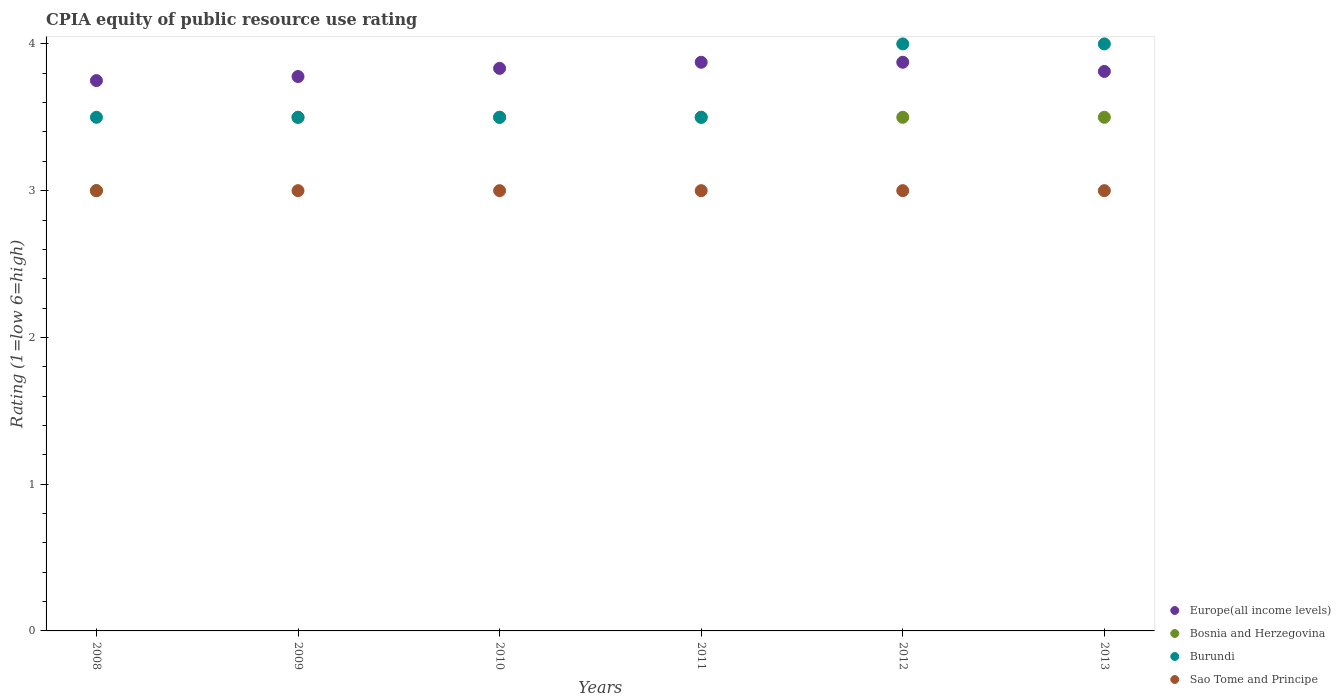Across all years, what is the minimum CPIA rating in Sao Tome and Principe?
Offer a very short reply. 3. In which year was the CPIA rating in Burundi minimum?
Provide a succinct answer. 2008. What is the total CPIA rating in Sao Tome and Principe in the graph?
Provide a succinct answer. 18. What is the difference between the CPIA rating in Bosnia and Herzegovina in 2011 and that in 2012?
Keep it short and to the point. 0. What is the difference between the CPIA rating in Sao Tome and Principe in 2013 and the CPIA rating in Burundi in 2012?
Offer a terse response. -1. What is the average CPIA rating in Sao Tome and Principe per year?
Make the answer very short. 3. In the year 2013, what is the difference between the CPIA rating in Sao Tome and Principe and CPIA rating in Burundi?
Provide a short and direct response. -1. What is the ratio of the CPIA rating in Burundi in 2012 to that in 2013?
Your response must be concise. 1. Is the difference between the CPIA rating in Sao Tome and Principe in 2011 and 2012 greater than the difference between the CPIA rating in Burundi in 2011 and 2012?
Offer a terse response. Yes. What is the difference between the highest and the lowest CPIA rating in Sao Tome and Principe?
Provide a short and direct response. 0. In how many years, is the CPIA rating in Burundi greater than the average CPIA rating in Burundi taken over all years?
Your answer should be compact. 2. Is the CPIA rating in Europe(all income levels) strictly greater than the CPIA rating in Bosnia and Herzegovina over the years?
Make the answer very short. Yes. Is the CPIA rating in Sao Tome and Principe strictly less than the CPIA rating in Bosnia and Herzegovina over the years?
Provide a short and direct response. No. How many years are there in the graph?
Provide a short and direct response. 6. What is the difference between two consecutive major ticks on the Y-axis?
Provide a succinct answer. 1. Does the graph contain any zero values?
Offer a very short reply. No. Does the graph contain grids?
Ensure brevity in your answer.  No. How are the legend labels stacked?
Your answer should be very brief. Vertical. What is the title of the graph?
Make the answer very short. CPIA equity of public resource use rating. What is the label or title of the X-axis?
Your answer should be compact. Years. What is the Rating (1=low 6=high) of Europe(all income levels) in 2008?
Offer a terse response. 3.75. What is the Rating (1=low 6=high) in Bosnia and Herzegovina in 2008?
Your response must be concise. 3. What is the Rating (1=low 6=high) in Europe(all income levels) in 2009?
Keep it short and to the point. 3.78. What is the Rating (1=low 6=high) of Bosnia and Herzegovina in 2009?
Make the answer very short. 3.5. What is the Rating (1=low 6=high) of Burundi in 2009?
Offer a very short reply. 3.5. What is the Rating (1=low 6=high) in Sao Tome and Principe in 2009?
Your response must be concise. 3. What is the Rating (1=low 6=high) in Europe(all income levels) in 2010?
Make the answer very short. 3.83. What is the Rating (1=low 6=high) in Burundi in 2010?
Your answer should be compact. 3.5. What is the Rating (1=low 6=high) of Sao Tome and Principe in 2010?
Provide a succinct answer. 3. What is the Rating (1=low 6=high) in Europe(all income levels) in 2011?
Provide a short and direct response. 3.88. What is the Rating (1=low 6=high) of Bosnia and Herzegovina in 2011?
Your answer should be very brief. 3.5. What is the Rating (1=low 6=high) of Europe(all income levels) in 2012?
Provide a short and direct response. 3.88. What is the Rating (1=low 6=high) in Sao Tome and Principe in 2012?
Your answer should be compact. 3. What is the Rating (1=low 6=high) of Europe(all income levels) in 2013?
Ensure brevity in your answer.  3.81. What is the Rating (1=low 6=high) in Bosnia and Herzegovina in 2013?
Keep it short and to the point. 3.5. What is the Rating (1=low 6=high) in Burundi in 2013?
Your response must be concise. 4. Across all years, what is the maximum Rating (1=low 6=high) of Europe(all income levels)?
Give a very brief answer. 3.88. Across all years, what is the minimum Rating (1=low 6=high) of Europe(all income levels)?
Make the answer very short. 3.75. Across all years, what is the minimum Rating (1=low 6=high) of Bosnia and Herzegovina?
Offer a terse response. 3. Across all years, what is the minimum Rating (1=low 6=high) of Burundi?
Offer a very short reply. 3.5. What is the total Rating (1=low 6=high) in Europe(all income levels) in the graph?
Ensure brevity in your answer.  22.92. What is the total Rating (1=low 6=high) of Bosnia and Herzegovina in the graph?
Your answer should be compact. 20.5. What is the total Rating (1=low 6=high) in Sao Tome and Principe in the graph?
Provide a succinct answer. 18. What is the difference between the Rating (1=low 6=high) in Europe(all income levels) in 2008 and that in 2009?
Provide a short and direct response. -0.03. What is the difference between the Rating (1=low 6=high) in Bosnia and Herzegovina in 2008 and that in 2009?
Offer a terse response. -0.5. What is the difference between the Rating (1=low 6=high) in Sao Tome and Principe in 2008 and that in 2009?
Keep it short and to the point. 0. What is the difference between the Rating (1=low 6=high) of Europe(all income levels) in 2008 and that in 2010?
Provide a short and direct response. -0.08. What is the difference between the Rating (1=low 6=high) in Bosnia and Herzegovina in 2008 and that in 2010?
Offer a very short reply. -0.5. What is the difference between the Rating (1=low 6=high) of Sao Tome and Principe in 2008 and that in 2010?
Your answer should be very brief. 0. What is the difference between the Rating (1=low 6=high) of Europe(all income levels) in 2008 and that in 2011?
Make the answer very short. -0.12. What is the difference between the Rating (1=low 6=high) in Burundi in 2008 and that in 2011?
Your answer should be compact. 0. What is the difference between the Rating (1=low 6=high) of Europe(all income levels) in 2008 and that in 2012?
Give a very brief answer. -0.12. What is the difference between the Rating (1=low 6=high) in Bosnia and Herzegovina in 2008 and that in 2012?
Keep it short and to the point. -0.5. What is the difference between the Rating (1=low 6=high) in Burundi in 2008 and that in 2012?
Offer a terse response. -0.5. What is the difference between the Rating (1=low 6=high) of Europe(all income levels) in 2008 and that in 2013?
Your answer should be very brief. -0.06. What is the difference between the Rating (1=low 6=high) of Burundi in 2008 and that in 2013?
Your answer should be very brief. -0.5. What is the difference between the Rating (1=low 6=high) in Sao Tome and Principe in 2008 and that in 2013?
Provide a succinct answer. 0. What is the difference between the Rating (1=low 6=high) of Europe(all income levels) in 2009 and that in 2010?
Keep it short and to the point. -0.06. What is the difference between the Rating (1=low 6=high) of Sao Tome and Principe in 2009 and that in 2010?
Your answer should be very brief. 0. What is the difference between the Rating (1=low 6=high) in Europe(all income levels) in 2009 and that in 2011?
Give a very brief answer. -0.1. What is the difference between the Rating (1=low 6=high) of Bosnia and Herzegovina in 2009 and that in 2011?
Offer a very short reply. 0. What is the difference between the Rating (1=low 6=high) of Burundi in 2009 and that in 2011?
Ensure brevity in your answer.  0. What is the difference between the Rating (1=low 6=high) in Sao Tome and Principe in 2009 and that in 2011?
Offer a terse response. 0. What is the difference between the Rating (1=low 6=high) in Europe(all income levels) in 2009 and that in 2012?
Ensure brevity in your answer.  -0.1. What is the difference between the Rating (1=low 6=high) in Bosnia and Herzegovina in 2009 and that in 2012?
Provide a succinct answer. 0. What is the difference between the Rating (1=low 6=high) of Europe(all income levels) in 2009 and that in 2013?
Your response must be concise. -0.03. What is the difference between the Rating (1=low 6=high) in Bosnia and Herzegovina in 2009 and that in 2013?
Offer a very short reply. 0. What is the difference between the Rating (1=low 6=high) in Burundi in 2009 and that in 2013?
Your answer should be very brief. -0.5. What is the difference between the Rating (1=low 6=high) of Europe(all income levels) in 2010 and that in 2011?
Your response must be concise. -0.04. What is the difference between the Rating (1=low 6=high) in Bosnia and Herzegovina in 2010 and that in 2011?
Your response must be concise. 0. What is the difference between the Rating (1=low 6=high) in Europe(all income levels) in 2010 and that in 2012?
Keep it short and to the point. -0.04. What is the difference between the Rating (1=low 6=high) in Sao Tome and Principe in 2010 and that in 2012?
Make the answer very short. 0. What is the difference between the Rating (1=low 6=high) in Europe(all income levels) in 2010 and that in 2013?
Provide a short and direct response. 0.02. What is the difference between the Rating (1=low 6=high) in Bosnia and Herzegovina in 2010 and that in 2013?
Your answer should be very brief. 0. What is the difference between the Rating (1=low 6=high) of Bosnia and Herzegovina in 2011 and that in 2012?
Your response must be concise. 0. What is the difference between the Rating (1=low 6=high) of Burundi in 2011 and that in 2012?
Keep it short and to the point. -0.5. What is the difference between the Rating (1=low 6=high) in Sao Tome and Principe in 2011 and that in 2012?
Offer a very short reply. 0. What is the difference between the Rating (1=low 6=high) of Europe(all income levels) in 2011 and that in 2013?
Make the answer very short. 0.06. What is the difference between the Rating (1=low 6=high) of Bosnia and Herzegovina in 2011 and that in 2013?
Provide a short and direct response. 0. What is the difference between the Rating (1=low 6=high) in Burundi in 2011 and that in 2013?
Keep it short and to the point. -0.5. What is the difference between the Rating (1=low 6=high) in Sao Tome and Principe in 2011 and that in 2013?
Your answer should be compact. 0. What is the difference between the Rating (1=low 6=high) of Europe(all income levels) in 2012 and that in 2013?
Offer a terse response. 0.06. What is the difference between the Rating (1=low 6=high) of Bosnia and Herzegovina in 2012 and that in 2013?
Give a very brief answer. 0. What is the difference between the Rating (1=low 6=high) of Burundi in 2012 and that in 2013?
Keep it short and to the point. 0. What is the difference between the Rating (1=low 6=high) of Sao Tome and Principe in 2012 and that in 2013?
Your answer should be compact. 0. What is the difference between the Rating (1=low 6=high) of Europe(all income levels) in 2008 and the Rating (1=low 6=high) of Bosnia and Herzegovina in 2009?
Ensure brevity in your answer.  0.25. What is the difference between the Rating (1=low 6=high) in Europe(all income levels) in 2008 and the Rating (1=low 6=high) in Sao Tome and Principe in 2009?
Offer a terse response. 0.75. What is the difference between the Rating (1=low 6=high) of Europe(all income levels) in 2008 and the Rating (1=low 6=high) of Bosnia and Herzegovina in 2010?
Your answer should be compact. 0.25. What is the difference between the Rating (1=low 6=high) in Europe(all income levels) in 2008 and the Rating (1=low 6=high) in Burundi in 2010?
Provide a succinct answer. 0.25. What is the difference between the Rating (1=low 6=high) in Europe(all income levels) in 2008 and the Rating (1=low 6=high) in Sao Tome and Principe in 2010?
Provide a succinct answer. 0.75. What is the difference between the Rating (1=low 6=high) of Bosnia and Herzegovina in 2008 and the Rating (1=low 6=high) of Sao Tome and Principe in 2010?
Your response must be concise. 0. What is the difference between the Rating (1=low 6=high) of Burundi in 2008 and the Rating (1=low 6=high) of Sao Tome and Principe in 2010?
Ensure brevity in your answer.  0.5. What is the difference between the Rating (1=low 6=high) in Europe(all income levels) in 2008 and the Rating (1=low 6=high) in Bosnia and Herzegovina in 2011?
Make the answer very short. 0.25. What is the difference between the Rating (1=low 6=high) of Bosnia and Herzegovina in 2008 and the Rating (1=low 6=high) of Burundi in 2011?
Provide a short and direct response. -0.5. What is the difference between the Rating (1=low 6=high) of Bosnia and Herzegovina in 2008 and the Rating (1=low 6=high) of Sao Tome and Principe in 2011?
Give a very brief answer. 0. What is the difference between the Rating (1=low 6=high) of Europe(all income levels) in 2008 and the Rating (1=low 6=high) of Bosnia and Herzegovina in 2012?
Provide a short and direct response. 0.25. What is the difference between the Rating (1=low 6=high) in Europe(all income levels) in 2008 and the Rating (1=low 6=high) in Burundi in 2012?
Your response must be concise. -0.25. What is the difference between the Rating (1=low 6=high) in Europe(all income levels) in 2008 and the Rating (1=low 6=high) in Sao Tome and Principe in 2012?
Make the answer very short. 0.75. What is the difference between the Rating (1=low 6=high) of Bosnia and Herzegovina in 2008 and the Rating (1=low 6=high) of Burundi in 2012?
Make the answer very short. -1. What is the difference between the Rating (1=low 6=high) of Europe(all income levels) in 2008 and the Rating (1=low 6=high) of Bosnia and Herzegovina in 2013?
Ensure brevity in your answer.  0.25. What is the difference between the Rating (1=low 6=high) of Bosnia and Herzegovina in 2008 and the Rating (1=low 6=high) of Burundi in 2013?
Your answer should be very brief. -1. What is the difference between the Rating (1=low 6=high) in Europe(all income levels) in 2009 and the Rating (1=low 6=high) in Bosnia and Herzegovina in 2010?
Keep it short and to the point. 0.28. What is the difference between the Rating (1=low 6=high) in Europe(all income levels) in 2009 and the Rating (1=low 6=high) in Burundi in 2010?
Provide a short and direct response. 0.28. What is the difference between the Rating (1=low 6=high) of Europe(all income levels) in 2009 and the Rating (1=low 6=high) of Sao Tome and Principe in 2010?
Keep it short and to the point. 0.78. What is the difference between the Rating (1=low 6=high) of Bosnia and Herzegovina in 2009 and the Rating (1=low 6=high) of Burundi in 2010?
Offer a terse response. 0. What is the difference between the Rating (1=low 6=high) in Bosnia and Herzegovina in 2009 and the Rating (1=low 6=high) in Sao Tome and Principe in 2010?
Make the answer very short. 0.5. What is the difference between the Rating (1=low 6=high) of Burundi in 2009 and the Rating (1=low 6=high) of Sao Tome and Principe in 2010?
Make the answer very short. 0.5. What is the difference between the Rating (1=low 6=high) of Europe(all income levels) in 2009 and the Rating (1=low 6=high) of Bosnia and Herzegovina in 2011?
Give a very brief answer. 0.28. What is the difference between the Rating (1=low 6=high) in Europe(all income levels) in 2009 and the Rating (1=low 6=high) in Burundi in 2011?
Provide a short and direct response. 0.28. What is the difference between the Rating (1=low 6=high) in Europe(all income levels) in 2009 and the Rating (1=low 6=high) in Sao Tome and Principe in 2011?
Your response must be concise. 0.78. What is the difference between the Rating (1=low 6=high) in Bosnia and Herzegovina in 2009 and the Rating (1=low 6=high) in Burundi in 2011?
Offer a very short reply. 0. What is the difference between the Rating (1=low 6=high) of Bosnia and Herzegovina in 2009 and the Rating (1=low 6=high) of Sao Tome and Principe in 2011?
Offer a terse response. 0.5. What is the difference between the Rating (1=low 6=high) in Europe(all income levels) in 2009 and the Rating (1=low 6=high) in Bosnia and Herzegovina in 2012?
Provide a succinct answer. 0.28. What is the difference between the Rating (1=low 6=high) of Europe(all income levels) in 2009 and the Rating (1=low 6=high) of Burundi in 2012?
Your answer should be compact. -0.22. What is the difference between the Rating (1=low 6=high) of Europe(all income levels) in 2009 and the Rating (1=low 6=high) of Sao Tome and Principe in 2012?
Your answer should be compact. 0.78. What is the difference between the Rating (1=low 6=high) of Europe(all income levels) in 2009 and the Rating (1=low 6=high) of Bosnia and Herzegovina in 2013?
Your response must be concise. 0.28. What is the difference between the Rating (1=low 6=high) in Europe(all income levels) in 2009 and the Rating (1=low 6=high) in Burundi in 2013?
Your response must be concise. -0.22. What is the difference between the Rating (1=low 6=high) in Burundi in 2009 and the Rating (1=low 6=high) in Sao Tome and Principe in 2013?
Provide a short and direct response. 0.5. What is the difference between the Rating (1=low 6=high) in Europe(all income levels) in 2010 and the Rating (1=low 6=high) in Burundi in 2011?
Offer a terse response. 0.33. What is the difference between the Rating (1=low 6=high) of Europe(all income levels) in 2010 and the Rating (1=low 6=high) of Sao Tome and Principe in 2011?
Your response must be concise. 0.83. What is the difference between the Rating (1=low 6=high) of Bosnia and Herzegovina in 2010 and the Rating (1=low 6=high) of Sao Tome and Principe in 2011?
Your answer should be very brief. 0.5. What is the difference between the Rating (1=low 6=high) in Burundi in 2010 and the Rating (1=low 6=high) in Sao Tome and Principe in 2011?
Give a very brief answer. 0.5. What is the difference between the Rating (1=low 6=high) of Europe(all income levels) in 2010 and the Rating (1=low 6=high) of Burundi in 2012?
Offer a terse response. -0.17. What is the difference between the Rating (1=low 6=high) of Europe(all income levels) in 2010 and the Rating (1=low 6=high) of Sao Tome and Principe in 2012?
Your answer should be very brief. 0.83. What is the difference between the Rating (1=low 6=high) of Bosnia and Herzegovina in 2010 and the Rating (1=low 6=high) of Burundi in 2012?
Provide a succinct answer. -0.5. What is the difference between the Rating (1=low 6=high) in Bosnia and Herzegovina in 2010 and the Rating (1=low 6=high) in Burundi in 2013?
Your response must be concise. -0.5. What is the difference between the Rating (1=low 6=high) of Burundi in 2010 and the Rating (1=low 6=high) of Sao Tome and Principe in 2013?
Your response must be concise. 0.5. What is the difference between the Rating (1=low 6=high) of Europe(all income levels) in 2011 and the Rating (1=low 6=high) of Burundi in 2012?
Offer a very short reply. -0.12. What is the difference between the Rating (1=low 6=high) in Bosnia and Herzegovina in 2011 and the Rating (1=low 6=high) in Burundi in 2012?
Your answer should be very brief. -0.5. What is the difference between the Rating (1=low 6=high) in Bosnia and Herzegovina in 2011 and the Rating (1=low 6=high) in Sao Tome and Principe in 2012?
Provide a succinct answer. 0.5. What is the difference between the Rating (1=low 6=high) in Europe(all income levels) in 2011 and the Rating (1=low 6=high) in Burundi in 2013?
Your answer should be very brief. -0.12. What is the difference between the Rating (1=low 6=high) of Bosnia and Herzegovina in 2011 and the Rating (1=low 6=high) of Sao Tome and Principe in 2013?
Offer a terse response. 0.5. What is the difference between the Rating (1=low 6=high) in Burundi in 2011 and the Rating (1=low 6=high) in Sao Tome and Principe in 2013?
Offer a very short reply. 0.5. What is the difference between the Rating (1=low 6=high) of Europe(all income levels) in 2012 and the Rating (1=low 6=high) of Bosnia and Herzegovina in 2013?
Provide a succinct answer. 0.38. What is the difference between the Rating (1=low 6=high) of Europe(all income levels) in 2012 and the Rating (1=low 6=high) of Burundi in 2013?
Your answer should be compact. -0.12. What is the difference between the Rating (1=low 6=high) in Europe(all income levels) in 2012 and the Rating (1=low 6=high) in Sao Tome and Principe in 2013?
Your response must be concise. 0.88. What is the difference between the Rating (1=low 6=high) in Bosnia and Herzegovina in 2012 and the Rating (1=low 6=high) in Burundi in 2013?
Your response must be concise. -0.5. What is the difference between the Rating (1=low 6=high) of Burundi in 2012 and the Rating (1=low 6=high) of Sao Tome and Principe in 2013?
Your answer should be very brief. 1. What is the average Rating (1=low 6=high) of Europe(all income levels) per year?
Make the answer very short. 3.82. What is the average Rating (1=low 6=high) in Bosnia and Herzegovina per year?
Offer a terse response. 3.42. What is the average Rating (1=low 6=high) in Burundi per year?
Provide a short and direct response. 3.67. In the year 2008, what is the difference between the Rating (1=low 6=high) in Europe(all income levels) and Rating (1=low 6=high) in Bosnia and Herzegovina?
Keep it short and to the point. 0.75. In the year 2008, what is the difference between the Rating (1=low 6=high) of Europe(all income levels) and Rating (1=low 6=high) of Burundi?
Make the answer very short. 0.25. In the year 2008, what is the difference between the Rating (1=low 6=high) in Europe(all income levels) and Rating (1=low 6=high) in Sao Tome and Principe?
Give a very brief answer. 0.75. In the year 2008, what is the difference between the Rating (1=low 6=high) of Bosnia and Herzegovina and Rating (1=low 6=high) of Burundi?
Make the answer very short. -0.5. In the year 2008, what is the difference between the Rating (1=low 6=high) of Bosnia and Herzegovina and Rating (1=low 6=high) of Sao Tome and Principe?
Your response must be concise. 0. In the year 2009, what is the difference between the Rating (1=low 6=high) in Europe(all income levels) and Rating (1=low 6=high) in Bosnia and Herzegovina?
Ensure brevity in your answer.  0.28. In the year 2009, what is the difference between the Rating (1=low 6=high) in Europe(all income levels) and Rating (1=low 6=high) in Burundi?
Your answer should be very brief. 0.28. In the year 2009, what is the difference between the Rating (1=low 6=high) of Bosnia and Herzegovina and Rating (1=low 6=high) of Burundi?
Provide a short and direct response. 0. In the year 2010, what is the difference between the Rating (1=low 6=high) of Bosnia and Herzegovina and Rating (1=low 6=high) of Burundi?
Ensure brevity in your answer.  0. In the year 2011, what is the difference between the Rating (1=low 6=high) in Europe(all income levels) and Rating (1=low 6=high) in Burundi?
Give a very brief answer. 0.38. In the year 2011, what is the difference between the Rating (1=low 6=high) of Europe(all income levels) and Rating (1=low 6=high) of Sao Tome and Principe?
Provide a short and direct response. 0.88. In the year 2011, what is the difference between the Rating (1=low 6=high) in Bosnia and Herzegovina and Rating (1=low 6=high) in Burundi?
Ensure brevity in your answer.  0. In the year 2011, what is the difference between the Rating (1=low 6=high) in Bosnia and Herzegovina and Rating (1=low 6=high) in Sao Tome and Principe?
Make the answer very short. 0.5. In the year 2012, what is the difference between the Rating (1=low 6=high) in Europe(all income levels) and Rating (1=low 6=high) in Bosnia and Herzegovina?
Offer a terse response. 0.38. In the year 2012, what is the difference between the Rating (1=low 6=high) of Europe(all income levels) and Rating (1=low 6=high) of Burundi?
Offer a very short reply. -0.12. In the year 2012, what is the difference between the Rating (1=low 6=high) in Europe(all income levels) and Rating (1=low 6=high) in Sao Tome and Principe?
Provide a short and direct response. 0.88. In the year 2012, what is the difference between the Rating (1=low 6=high) in Bosnia and Herzegovina and Rating (1=low 6=high) in Burundi?
Provide a succinct answer. -0.5. In the year 2012, what is the difference between the Rating (1=low 6=high) in Burundi and Rating (1=low 6=high) in Sao Tome and Principe?
Keep it short and to the point. 1. In the year 2013, what is the difference between the Rating (1=low 6=high) of Europe(all income levels) and Rating (1=low 6=high) of Bosnia and Herzegovina?
Offer a terse response. 0.31. In the year 2013, what is the difference between the Rating (1=low 6=high) of Europe(all income levels) and Rating (1=low 6=high) of Burundi?
Provide a short and direct response. -0.19. In the year 2013, what is the difference between the Rating (1=low 6=high) of Europe(all income levels) and Rating (1=low 6=high) of Sao Tome and Principe?
Make the answer very short. 0.81. In the year 2013, what is the difference between the Rating (1=low 6=high) in Bosnia and Herzegovina and Rating (1=low 6=high) in Sao Tome and Principe?
Ensure brevity in your answer.  0.5. In the year 2013, what is the difference between the Rating (1=low 6=high) in Burundi and Rating (1=low 6=high) in Sao Tome and Principe?
Your answer should be compact. 1. What is the ratio of the Rating (1=low 6=high) of Burundi in 2008 to that in 2009?
Your answer should be compact. 1. What is the ratio of the Rating (1=low 6=high) of Sao Tome and Principe in 2008 to that in 2009?
Ensure brevity in your answer.  1. What is the ratio of the Rating (1=low 6=high) of Europe(all income levels) in 2008 to that in 2010?
Give a very brief answer. 0.98. What is the ratio of the Rating (1=low 6=high) of Sao Tome and Principe in 2008 to that in 2010?
Your answer should be compact. 1. What is the ratio of the Rating (1=low 6=high) of Bosnia and Herzegovina in 2008 to that in 2012?
Offer a very short reply. 0.86. What is the ratio of the Rating (1=low 6=high) in Burundi in 2008 to that in 2012?
Offer a terse response. 0.88. What is the ratio of the Rating (1=low 6=high) of Europe(all income levels) in 2008 to that in 2013?
Your answer should be compact. 0.98. What is the ratio of the Rating (1=low 6=high) in Bosnia and Herzegovina in 2008 to that in 2013?
Your response must be concise. 0.86. What is the ratio of the Rating (1=low 6=high) of Europe(all income levels) in 2009 to that in 2010?
Ensure brevity in your answer.  0.99. What is the ratio of the Rating (1=low 6=high) in Europe(all income levels) in 2009 to that in 2011?
Offer a terse response. 0.97. What is the ratio of the Rating (1=low 6=high) of Bosnia and Herzegovina in 2009 to that in 2011?
Your response must be concise. 1. What is the ratio of the Rating (1=low 6=high) in Sao Tome and Principe in 2009 to that in 2011?
Offer a terse response. 1. What is the ratio of the Rating (1=low 6=high) in Europe(all income levels) in 2009 to that in 2012?
Provide a short and direct response. 0.97. What is the ratio of the Rating (1=low 6=high) in Bosnia and Herzegovina in 2009 to that in 2012?
Ensure brevity in your answer.  1. What is the ratio of the Rating (1=low 6=high) of Europe(all income levels) in 2009 to that in 2013?
Provide a succinct answer. 0.99. What is the ratio of the Rating (1=low 6=high) of Bosnia and Herzegovina in 2009 to that in 2013?
Make the answer very short. 1. What is the ratio of the Rating (1=low 6=high) in Burundi in 2009 to that in 2013?
Your response must be concise. 0.88. What is the ratio of the Rating (1=low 6=high) of Sao Tome and Principe in 2009 to that in 2013?
Give a very brief answer. 1. What is the ratio of the Rating (1=low 6=high) in Europe(all income levels) in 2010 to that in 2011?
Offer a terse response. 0.99. What is the ratio of the Rating (1=low 6=high) of Bosnia and Herzegovina in 2010 to that in 2011?
Your response must be concise. 1. What is the ratio of the Rating (1=low 6=high) in Burundi in 2010 to that in 2011?
Keep it short and to the point. 1. What is the ratio of the Rating (1=low 6=high) in Sao Tome and Principe in 2010 to that in 2011?
Make the answer very short. 1. What is the ratio of the Rating (1=low 6=high) of Bosnia and Herzegovina in 2010 to that in 2012?
Give a very brief answer. 1. What is the ratio of the Rating (1=low 6=high) of Burundi in 2010 to that in 2012?
Offer a terse response. 0.88. What is the ratio of the Rating (1=low 6=high) of Sao Tome and Principe in 2010 to that in 2013?
Offer a very short reply. 1. What is the ratio of the Rating (1=low 6=high) of Europe(all income levels) in 2011 to that in 2012?
Give a very brief answer. 1. What is the ratio of the Rating (1=low 6=high) of Burundi in 2011 to that in 2012?
Give a very brief answer. 0.88. What is the ratio of the Rating (1=low 6=high) in Europe(all income levels) in 2011 to that in 2013?
Provide a short and direct response. 1.02. What is the ratio of the Rating (1=low 6=high) in Burundi in 2011 to that in 2013?
Ensure brevity in your answer.  0.88. What is the ratio of the Rating (1=low 6=high) of Europe(all income levels) in 2012 to that in 2013?
Give a very brief answer. 1.02. What is the difference between the highest and the second highest Rating (1=low 6=high) in Europe(all income levels)?
Make the answer very short. 0. What is the difference between the highest and the second highest Rating (1=low 6=high) in Burundi?
Your response must be concise. 0. What is the difference between the highest and the lowest Rating (1=low 6=high) of Burundi?
Make the answer very short. 0.5. 